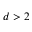<formula> <loc_0><loc_0><loc_500><loc_500>d > 2</formula> 